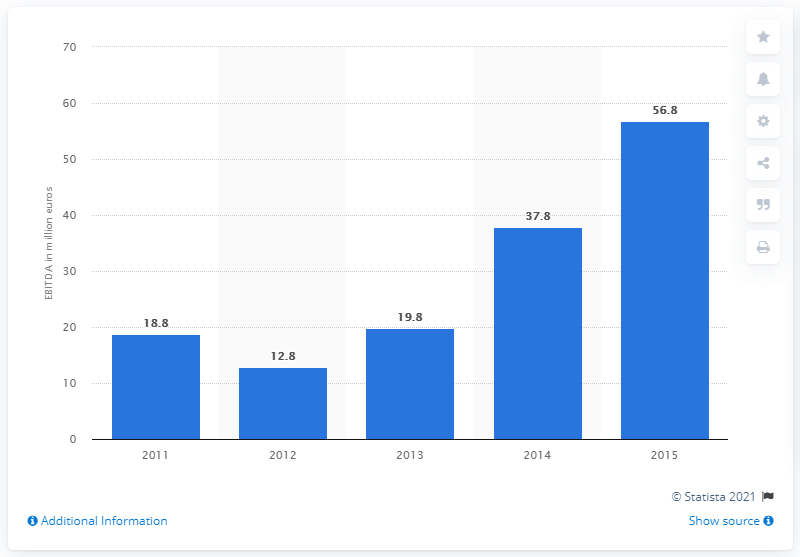Draw attention to some important aspects in this diagram. The EBITDA of Versace in 2015 was 56.8 million. 